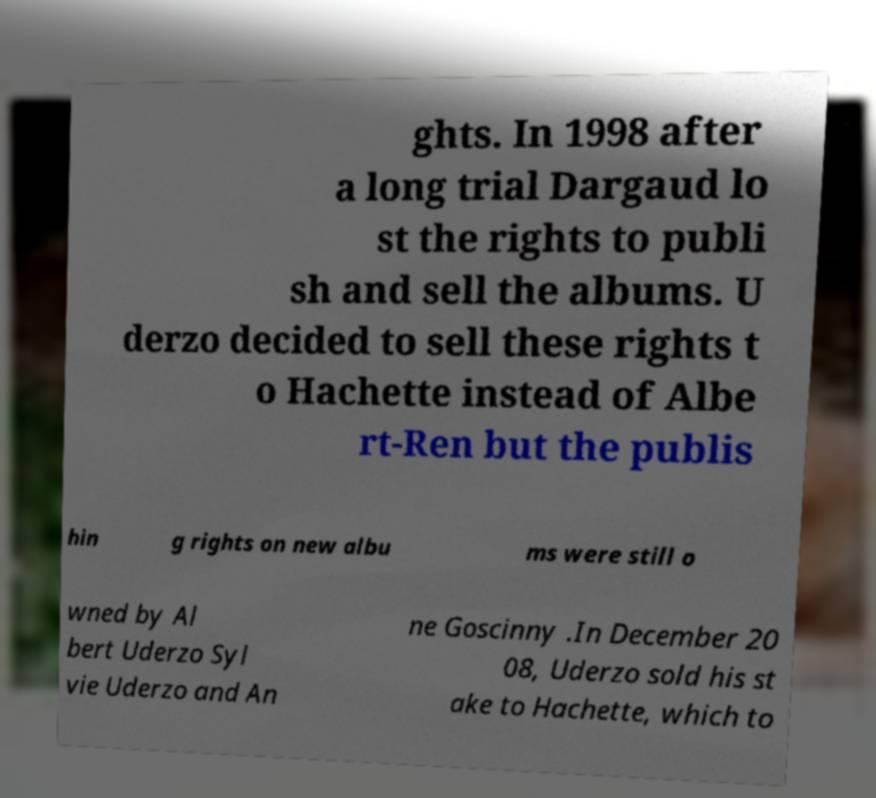Please read and relay the text visible in this image. What does it say? ghts. In 1998 after a long trial Dargaud lo st the rights to publi sh and sell the albums. U derzo decided to sell these rights t o Hachette instead of Albe rt-Ren but the publis hin g rights on new albu ms were still o wned by Al bert Uderzo Syl vie Uderzo and An ne Goscinny .In December 20 08, Uderzo sold his st ake to Hachette, which to 